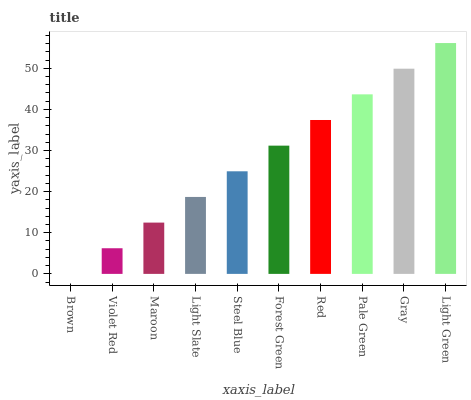Is Brown the minimum?
Answer yes or no. Yes. Is Light Green the maximum?
Answer yes or no. Yes. Is Violet Red the minimum?
Answer yes or no. No. Is Violet Red the maximum?
Answer yes or no. No. Is Violet Red greater than Brown?
Answer yes or no. Yes. Is Brown less than Violet Red?
Answer yes or no. Yes. Is Brown greater than Violet Red?
Answer yes or no. No. Is Violet Red less than Brown?
Answer yes or no. No. Is Forest Green the high median?
Answer yes or no. Yes. Is Steel Blue the low median?
Answer yes or no. Yes. Is Pale Green the high median?
Answer yes or no. No. Is Forest Green the low median?
Answer yes or no. No. 